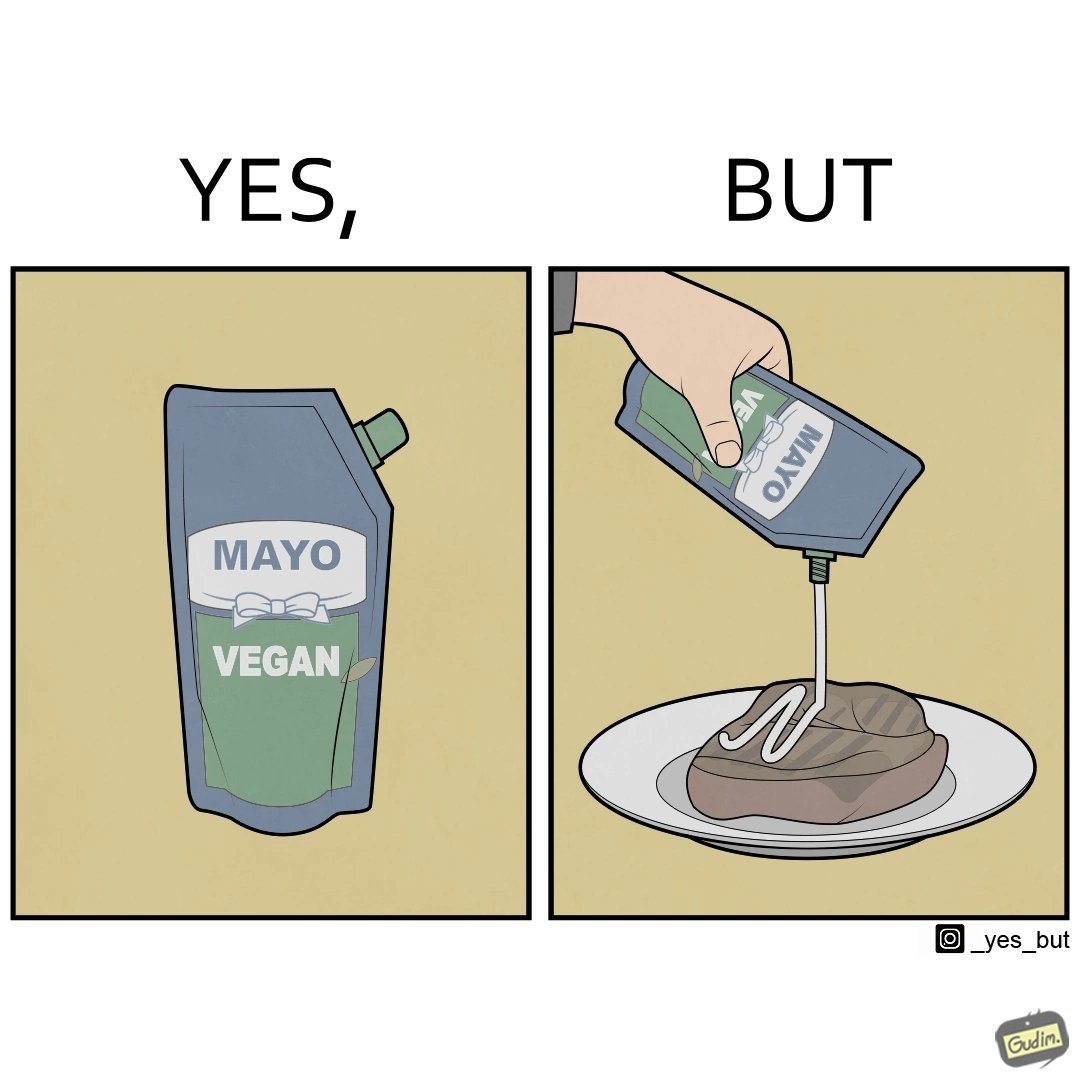Is this a satirical image? Yes, this image is satirical. 